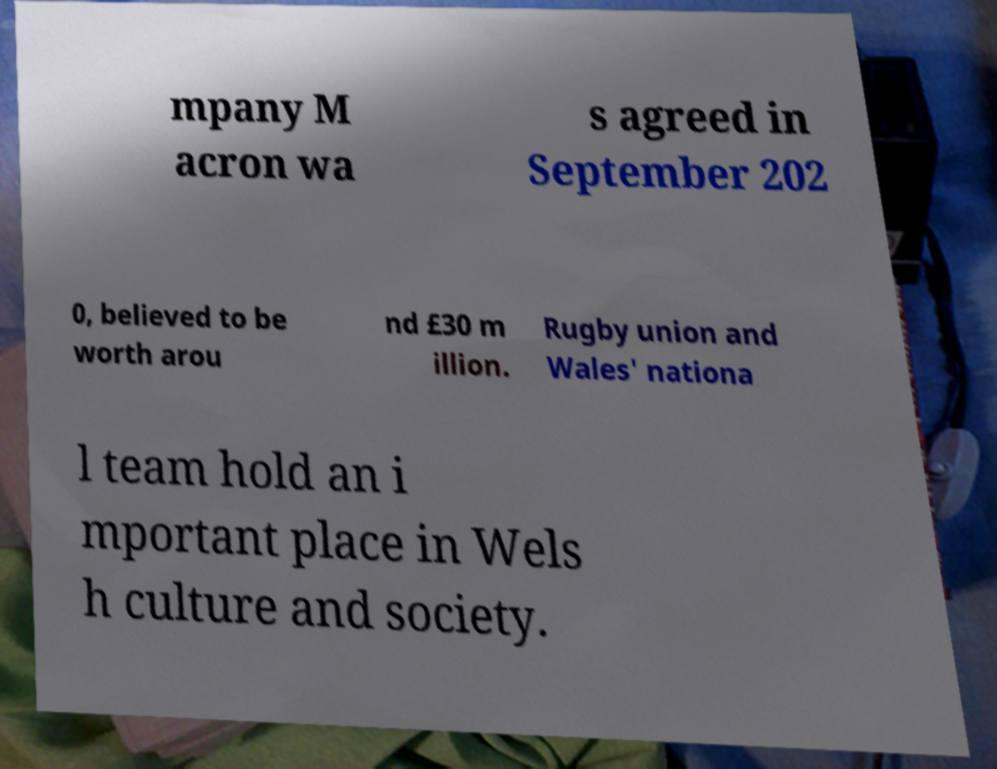Could you assist in decoding the text presented in this image and type it out clearly? mpany M acron wa s agreed in September 202 0, believed to be worth arou nd £30 m illion. Rugby union and Wales' nationa l team hold an i mportant place in Wels h culture and society. 